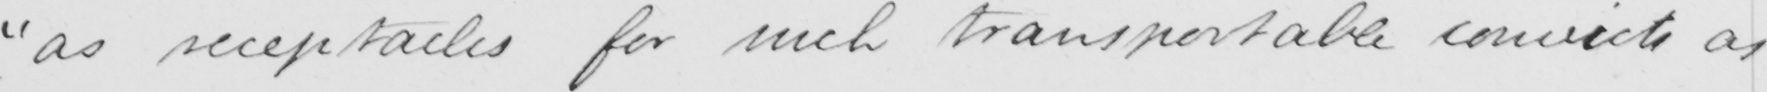What is written in this line of handwriting? " as receptacles for such transportable convicts as 